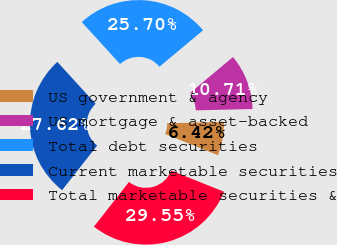<chart> <loc_0><loc_0><loc_500><loc_500><pie_chart><fcel>US government & agency<fcel>US mortgage & asset-backed<fcel>Total debt securities<fcel>Current marketable securities<fcel>Total marketable securities &<nl><fcel>6.42%<fcel>10.71%<fcel>25.7%<fcel>27.62%<fcel>29.55%<nl></chart> 